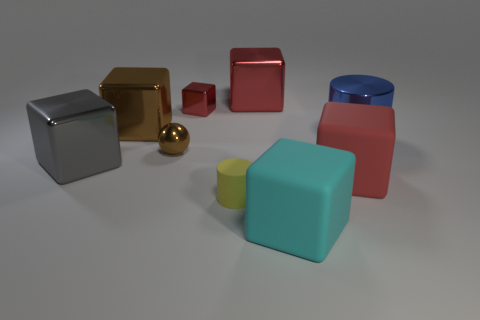Subtract all red blocks. How many were subtracted if there are1red blocks left? 2 Subtract all large gray cubes. How many cubes are left? 5 Subtract all red balls. How many red blocks are left? 3 Subtract all red cubes. How many cubes are left? 3 Subtract all balls. How many objects are left? 8 Add 9 big purple cylinders. How many big purple cylinders exist? 9 Subtract 1 gray blocks. How many objects are left? 8 Subtract all gray blocks. Subtract all purple spheres. How many blocks are left? 5 Subtract all matte cubes. Subtract all big gray metallic things. How many objects are left? 6 Add 6 yellow rubber objects. How many yellow rubber objects are left? 7 